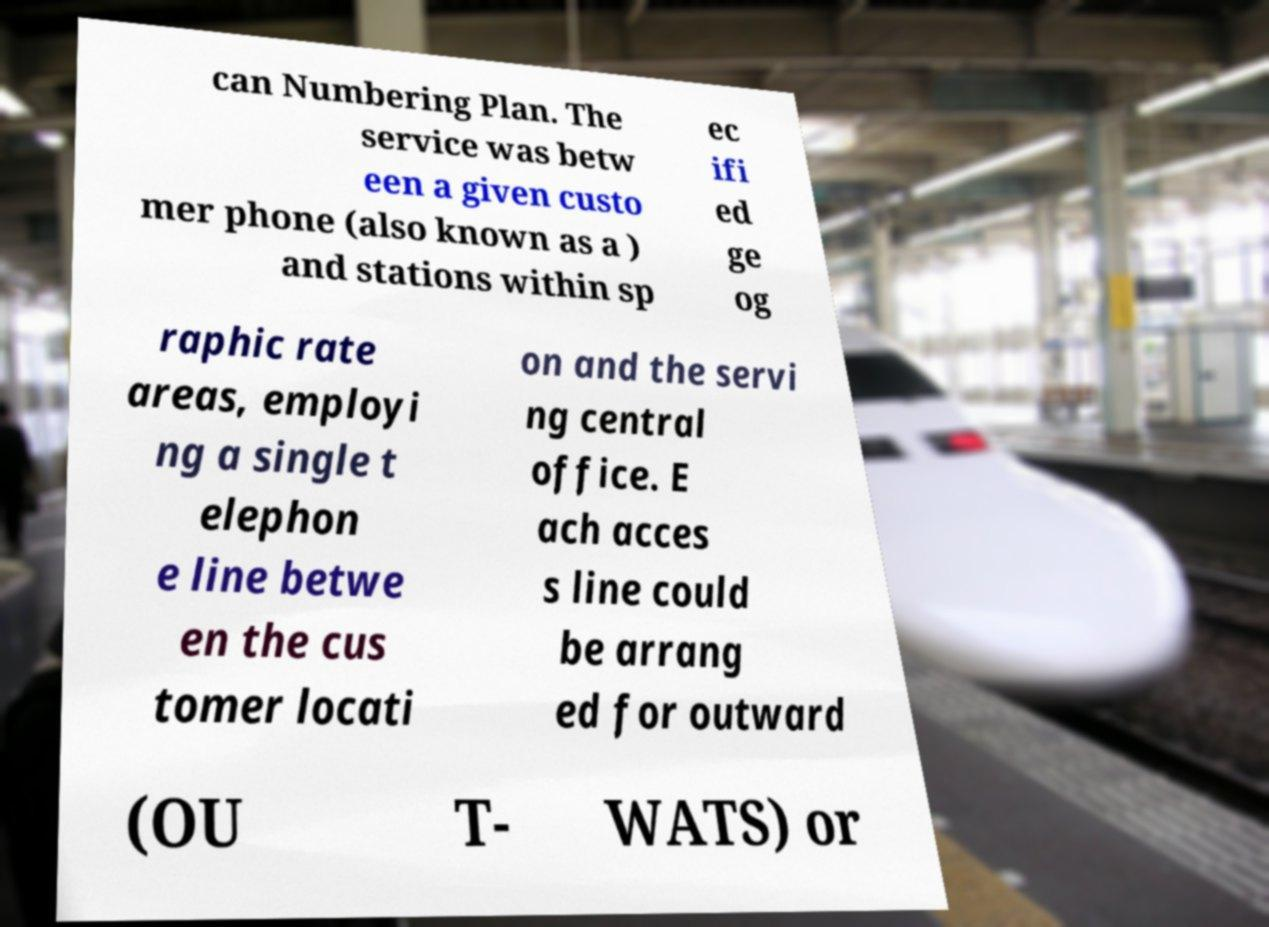I need the written content from this picture converted into text. Can you do that? can Numbering Plan. The service was betw een a given custo mer phone (also known as a ) and stations within sp ec ifi ed ge og raphic rate areas, employi ng a single t elephon e line betwe en the cus tomer locati on and the servi ng central office. E ach acces s line could be arrang ed for outward (OU T- WATS) or 